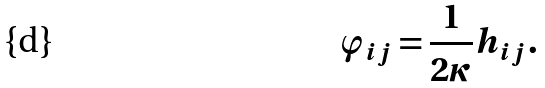<formula> <loc_0><loc_0><loc_500><loc_500>\varphi _ { i j } = \frac { 1 } { 2 \kappa } h _ { i j } .</formula> 